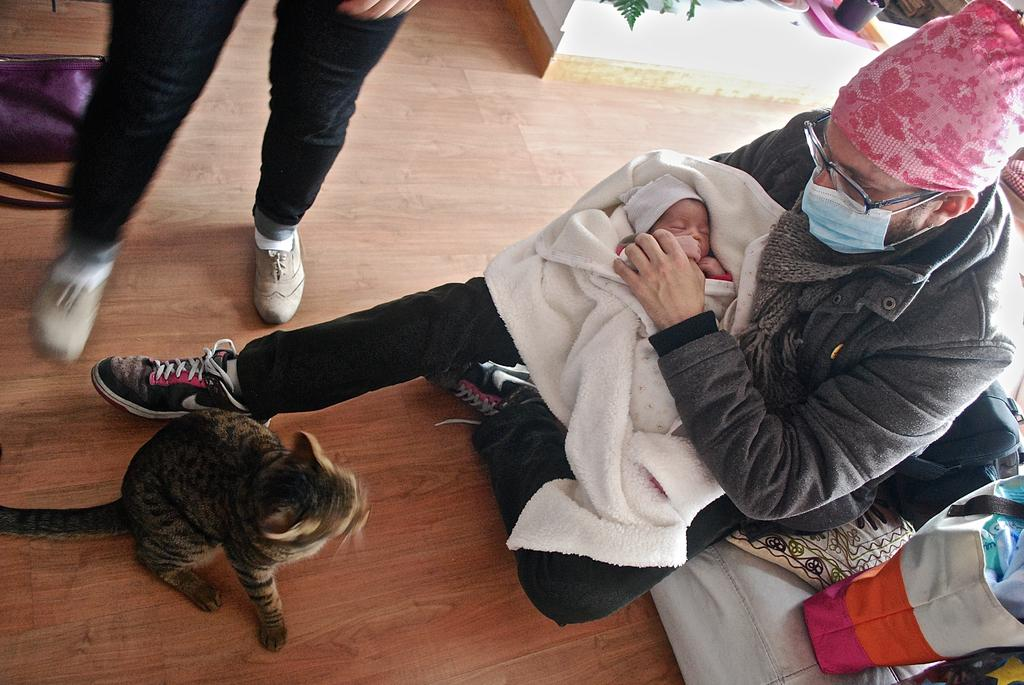What animal is sitting on the floor in the image? There is a cat sitting on the floor in the image. What piece of furniture is to the right of the cat? There is a sofa to the right of the cat. What is on the sofa? A bag is on the sofa. What is happening on the sofa? A person is sitting on the sofa holding a baby. What is happening at the left back of the image? A person is standing at the left back. What holiday is being celebrated in the image? There is no indication of a holiday being celebrated in the image. What color is the system in the image? There is no system present in the image, so it is not possible to determine its color. 